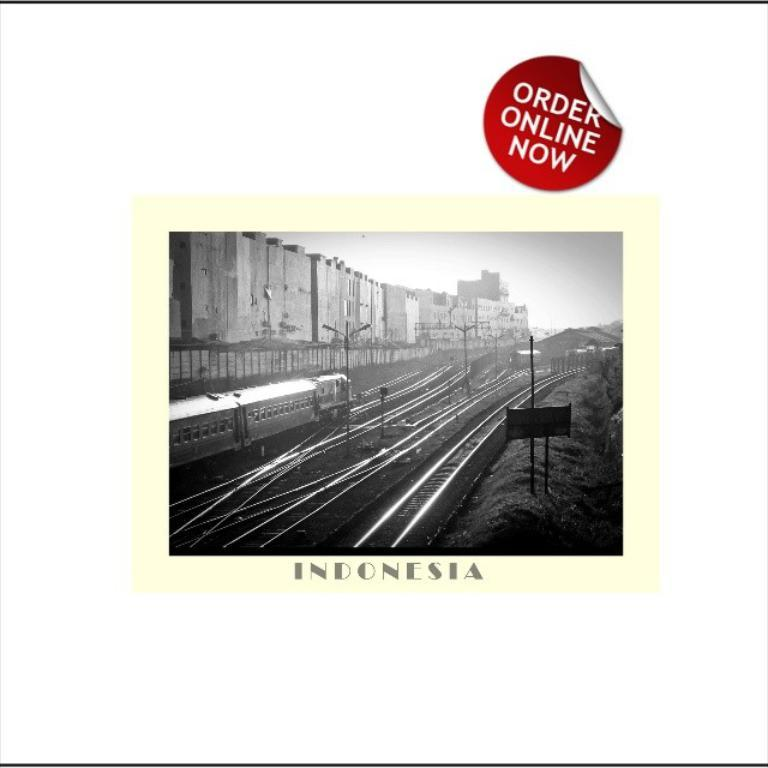What is the main subject of the poster in the image? The poster contains a black and white picture of a train on a train track. What else can be seen in the image besides the poster? There are buildings visible in the image. Is there any text present in the image? Yes, there is text present in the image. What can be seen in the sky in the image? The sky is visible in the image. How many rings are hanging from the train in the image? There are no rings present in the image; it features a black and white picture of a train on a train track. What type of stocking is visible on the train in the image? There is no stocking present in the image; it features a black and white picture of a train on a train track. 